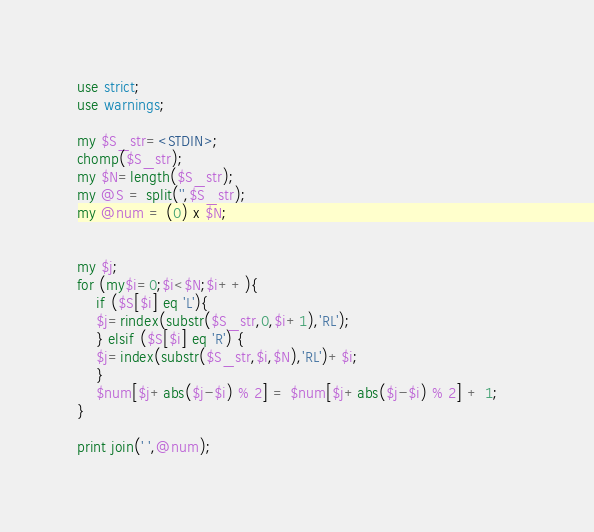Convert code to text. <code><loc_0><loc_0><loc_500><loc_500><_Perl_>use strict;
use warnings;

my $S_str=<STDIN>;
chomp($S_str);
my $N=length($S_str);
my @S = split('',$S_str);
my @num = (0) x $N;


my $j;
for (my$i=0;$i<$N;$i++){
    if ($S[$i] eq 'L'){
	$j=rindex(substr($S_str,0,$i+1),'RL');
    } elsif ($S[$i] eq 'R') {
	$j=index(substr($S_str,$i,$N),'RL')+$i;
    }
    $num[$j+abs($j-$i) % 2] = $num[$j+abs($j-$i) % 2] + 1;    
}

print join(' ',@num);
</code> 